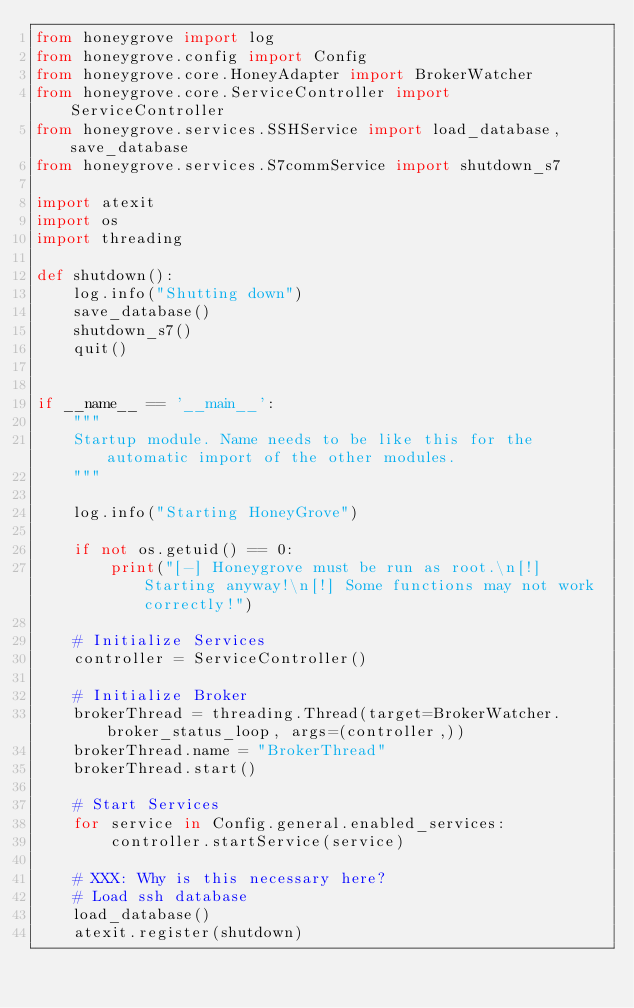Convert code to text. <code><loc_0><loc_0><loc_500><loc_500><_Python_>from honeygrove import log
from honeygrove.config import Config
from honeygrove.core.HoneyAdapter import BrokerWatcher
from honeygrove.core.ServiceController import ServiceController
from honeygrove.services.SSHService import load_database, save_database
from honeygrove.services.S7commService import shutdown_s7

import atexit
import os
import threading

def shutdown():
    log.info("Shutting down")
    save_database()
    shutdown_s7()
    quit()


if __name__ == '__main__':
    """
    Startup module. Name needs to be like this for the automatic import of the other modules.
    """

    log.info("Starting HoneyGrove")

    if not os.getuid() == 0:
        print("[-] Honeygrove must be run as root.\n[!] Starting anyway!\n[!] Some functions may not work correctly!")

    # Initialize Services
    controller = ServiceController()

    # Initialize Broker
    brokerThread = threading.Thread(target=BrokerWatcher.broker_status_loop, args=(controller,))
    brokerThread.name = "BrokerThread"
    brokerThread.start()

    # Start Services
    for service in Config.general.enabled_services:
        controller.startService(service)

    # XXX: Why is this necessary here?
    # Load ssh database
    load_database()
    atexit.register(shutdown)

</code> 